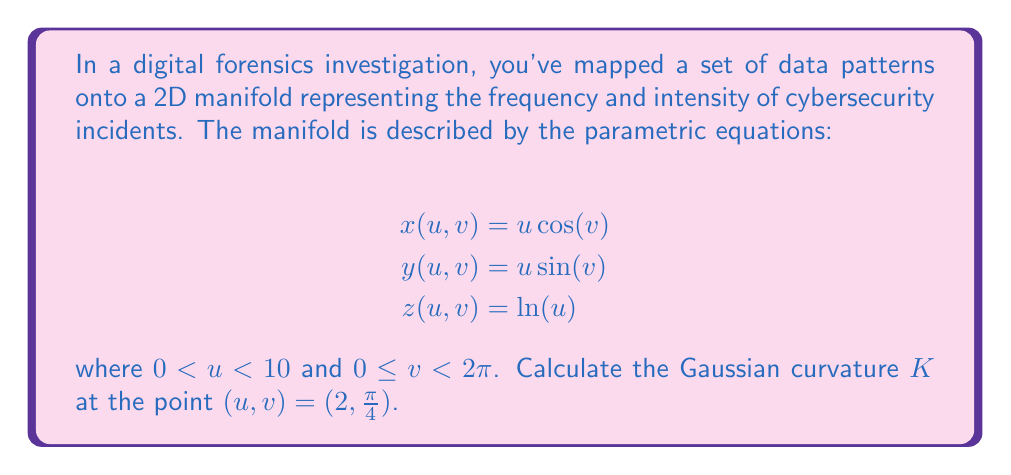Provide a solution to this math problem. To calculate the Gaussian curvature of a 2D manifold embedded in 3D space, we need to follow these steps:

1) First, we need to calculate the first fundamental form coefficients $E$, $F$, and $G$:

   $$E = x_u^2 + y_u^2 + z_u^2$$
   $$F = x_u x_v + y_u y_v + z_u z_v$$
   $$G = x_v^2 + y_v^2 + z_v^2$$

2) Then, we calculate the second fundamental form coefficients $L$, $M$, and $N$:

   $$L = \frac{x_{uu}N_x + y_{uu}N_y + z_{uu}N_z}{\sqrt{EG-F^2}}$$
   $$M = \frac{x_{uv}N_x + y_{uv}N_y + z_{uv}N_z}{\sqrt{EG-F^2}}$$
   $$N = \frac{x_{vv}N_x + y_{vv}N_y + z_{vv}N_z}{\sqrt{EG-F^2}}$$

   where $N_x$, $N_y$, and $N_z$ are the components of the unit normal vector.

3) Finally, we can calculate the Gaussian curvature:

   $$K = \frac{LN - M^2}{EG - F^2}$$

Let's perform these calculations:

1) First derivatives:
   $$x_u = \cos(v), \quad x_v = -u\sin(v)$$
   $$y_u = \sin(v), \quad y_v = u\cos(v)$$
   $$z_u = \frac{1}{u}, \quad z_v = 0$$

2) Second derivatives:
   $$x_{uu} = 0, \quad x_{uv} = -\sin(v), \quad x_{vv} = -u\cos(v)$$
   $$y_{uu} = 0, \quad y_{uv} = \cos(v), \quad y_{vv} = -u\sin(v)$$
   $$z_{uu} = -\frac{1}{u^2}, \quad z_{uv} = 0, \quad z_{vv} = 0$$

3) Calculating $E$, $F$, and $G$:
   $$E = \cos^2(v) + \sin^2(v) + \frac{1}{u^2} = 1 + \frac{1}{u^2}$$
   $$F = -u\sin(v)\cos(v) + u\sin(v)\cos(v) + 0 = 0$$
   $$G = u^2\sin^2(v) + u^2\cos^2(v) + 0 = u^2$$

4) The unit normal vector:
   $$\vec{N} = \frac{1}{\sqrt{u^2 + 1}}(-u\cos(v), -u\sin(v), 1)$$

5) Calculating $L$, $M$, and $N$:
   $$L = \frac{-\frac{1}{u^2}}{\sqrt{u^2 + 1}}$$
   $$M = 0$$
   $$N = \frac{u}{\sqrt{u^2 + 1}}$$

6) Finally, the Gaussian curvature:
   $$K = \frac{LN - M^2}{EG - F^2} = \frac{(-\frac{1}{u^2})(\frac{u}{\sqrt{u^2 + 1}}) - 0}{(1 + \frac{1}{u^2})(u^2) - 0} = -\frac{1}{u^2(u^2 + 1)}$$

At the point $(u,v) = (2,\frac{\pi}{4})$, we have:

$$K = -\frac{1}{2^2(2^2 + 1)} = -\frac{1}{20}$$
Answer: The Gaussian curvature at the point $(u,v) = (2,\frac{\pi}{4})$ is $K = -\frac{1}{20}$. 